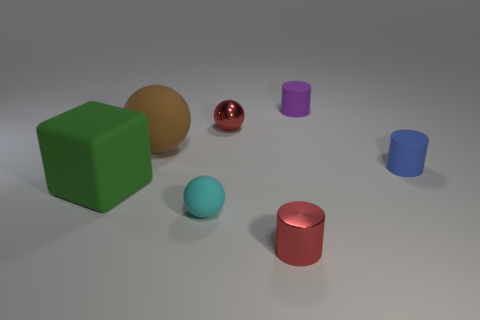Add 2 big purple cylinders. How many objects exist? 9 Subtract all cylinders. How many objects are left? 4 Subtract all tiny matte cylinders. Subtract all red shiny spheres. How many objects are left? 4 Add 7 tiny red cylinders. How many tiny red cylinders are left? 8 Add 1 big red rubber cylinders. How many big red rubber cylinders exist? 1 Subtract 0 green cylinders. How many objects are left? 7 